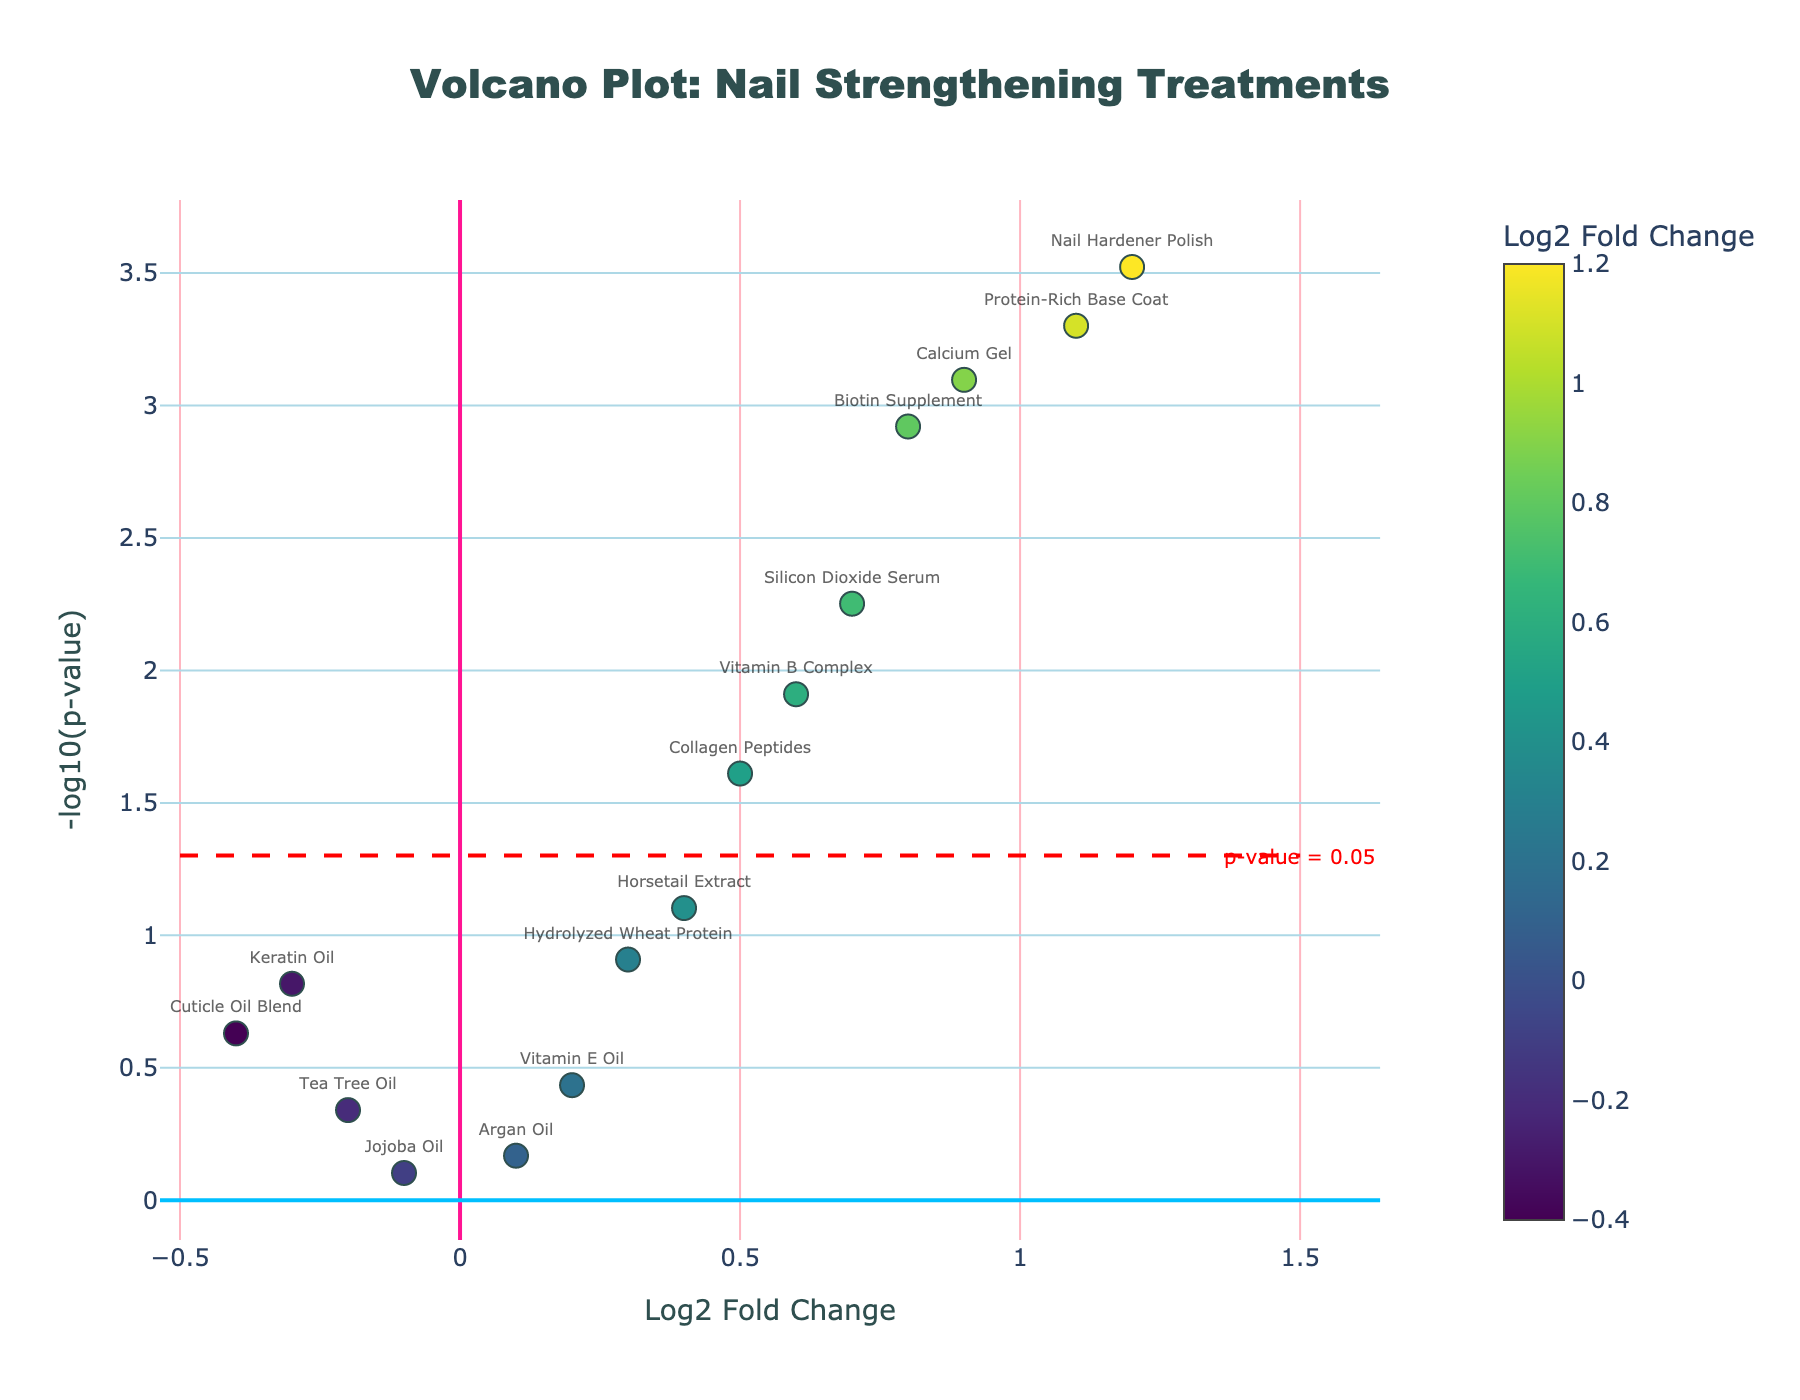What's the title of the plot? The title is usually placed at the top center of the figure. In this plot, it's located in that position and reads "Volcano Plot: Nail Strengthening Treatments".
Answer: Volcano Plot: Nail Strengthening Treatments What does the x-axis represent? The x-axis label is typically placed below the axis. Here, it reads "Log2 Fold Change", indicating the x-axis represents log2 fold changes of treatments.
Answer: Log2 Fold Change Which treatment has the highest log2 fold change? Look for the data point farthest to the right on the x-axis. The label closest to this point is "Nail Hardener Polish" with a log2 fold change of 1.2.
Answer: Nail Hardener Polish How many treatments have a significantly low p-value (below 0.05)? The significant p-value threshold is indicated by a horizontal dashed red line at -log10(p-value) = 1.3 (since -log10(0.05) ≈ 1.3). Count the number of points above this line. There are 7 treatments meeting this criteria.
Answer: 7 Which treatment has the highest -log10(p-value)? The y-axis represents -log10(p-value). The highest point on this axis corresponds to "Nail Hardener Polish".
Answer: Nail Hardener Polish Among Biotin Supplement, Keratin Oil, and Vitamin B Complex, which has the lowest -log10(p-value)? Check the positions of the mentioned treatments on the y-axis and see which one is the lowest. "Keratin Oil" has the lowest -log10(p-value).
Answer: Keratin Oil What is the log2 fold change for Protein-Rich Base Coat? Look for the position of "Protein-Rich Base Coat" on the x-axis. According to the hover text, the log2 fold change is 1.1.
Answer: 1.1 Which treatment had the least effect on nail growth rate and brittleness as suggested by log2 fold change? The closer a data point is to 0 on the x-axis, the less effect it has. "Jojoba Oil" has a log2 fold change of -0.1, which is closest to 0.
Answer: Jojoba Oil If a treatment is considered effective when its log2 fold change is above 0.5 and p-value is below 0.05, how many treatments are effective? Identify treatments with log2 fold change > 0.5 and -log10(p-value) > 1.3. The effective treatments are "Protein-Rich Base Coat", "Nail Hardener Polish", "Calcium Gel", "Silicon Dioxide Serum", and "Biotin Supplement", totaling 5.
Answer: 5 